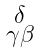<formula> <loc_0><loc_0><loc_500><loc_500>\begin{smallmatrix} \delta \\ \gamma \beta \end{smallmatrix}</formula> 